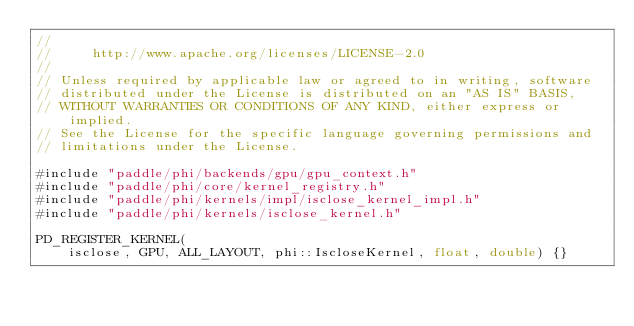<code> <loc_0><loc_0><loc_500><loc_500><_Cuda_>//
//     http://www.apache.org/licenses/LICENSE-2.0
//
// Unless required by applicable law or agreed to in writing, software
// distributed under the License is distributed on an "AS IS" BASIS,
// WITHOUT WARRANTIES OR CONDITIONS OF ANY KIND, either express or implied.
// See the License for the specific language governing permissions and
// limitations under the License.

#include "paddle/phi/backends/gpu/gpu_context.h"
#include "paddle/phi/core/kernel_registry.h"
#include "paddle/phi/kernels/impl/isclose_kernel_impl.h"
#include "paddle/phi/kernels/isclose_kernel.h"

PD_REGISTER_KERNEL(
    isclose, GPU, ALL_LAYOUT, phi::IscloseKernel, float, double) {}
</code> 